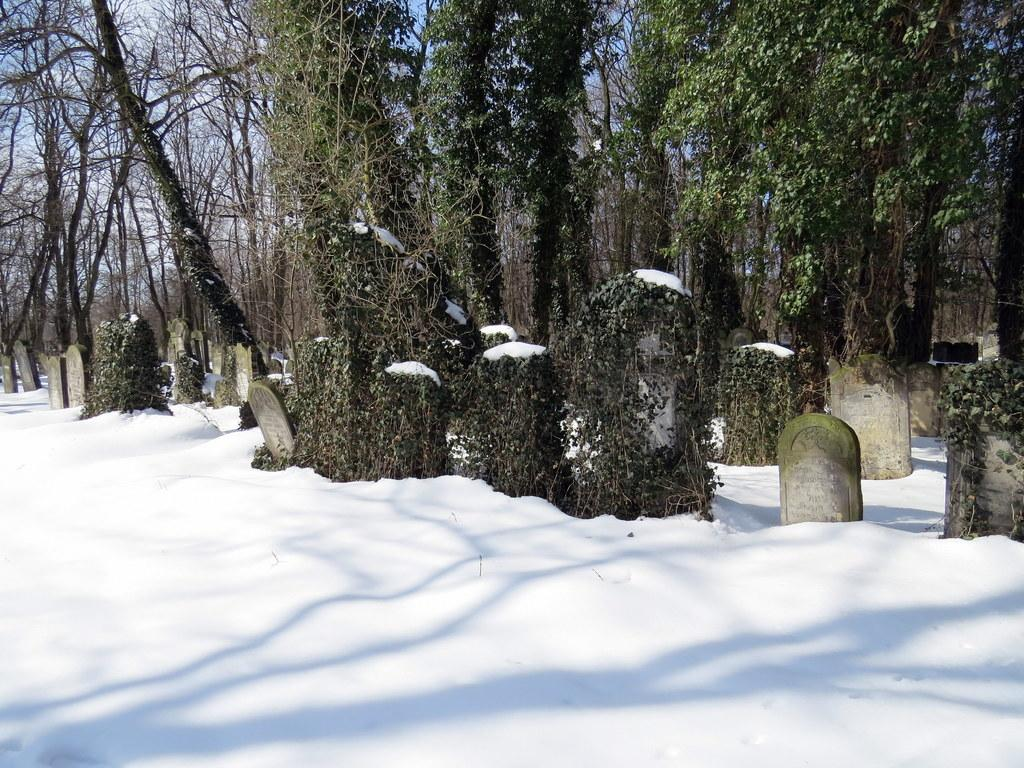What type of location is shown in the image? The location depicted in the image is a graveyard. What is the ground covered with at the bottom of the image? There is snow at the bottom of the image. What type of vegetation can be seen in the background of the image? There are many creeper plants and trees in the background of the image. What type of street is visible in the image? There is no street visible in the image; it is set in a graveyard. Who is competing in the push-up competition in the image? There is no push-up competition present in the image. 